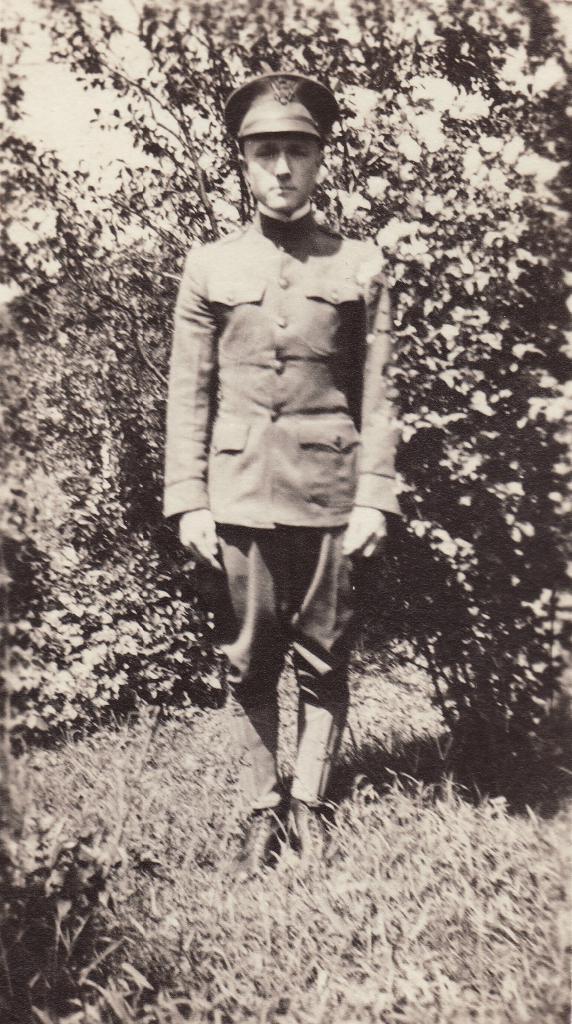In one or two sentences, can you explain what this image depicts? In this picture I can see there is a man standing here he is wearing a coat, hat and pant. He is standing on the grass and there are plants in the backdrop. 